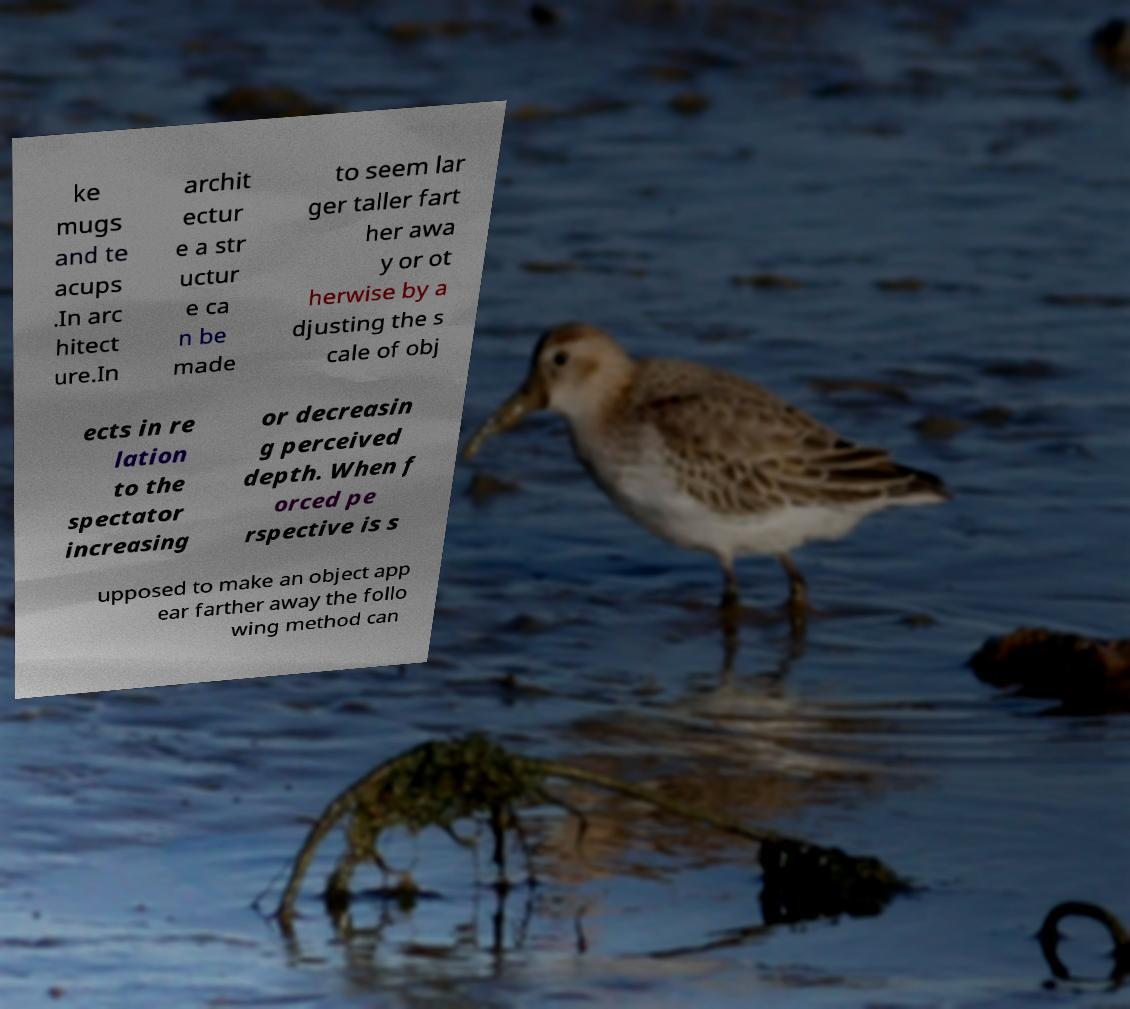Could you assist in decoding the text presented in this image and type it out clearly? ke mugs and te acups .In arc hitect ure.In archit ectur e a str uctur e ca n be made to seem lar ger taller fart her awa y or ot herwise by a djusting the s cale of obj ects in re lation to the spectator increasing or decreasin g perceived depth. When f orced pe rspective is s upposed to make an object app ear farther away the follo wing method can 